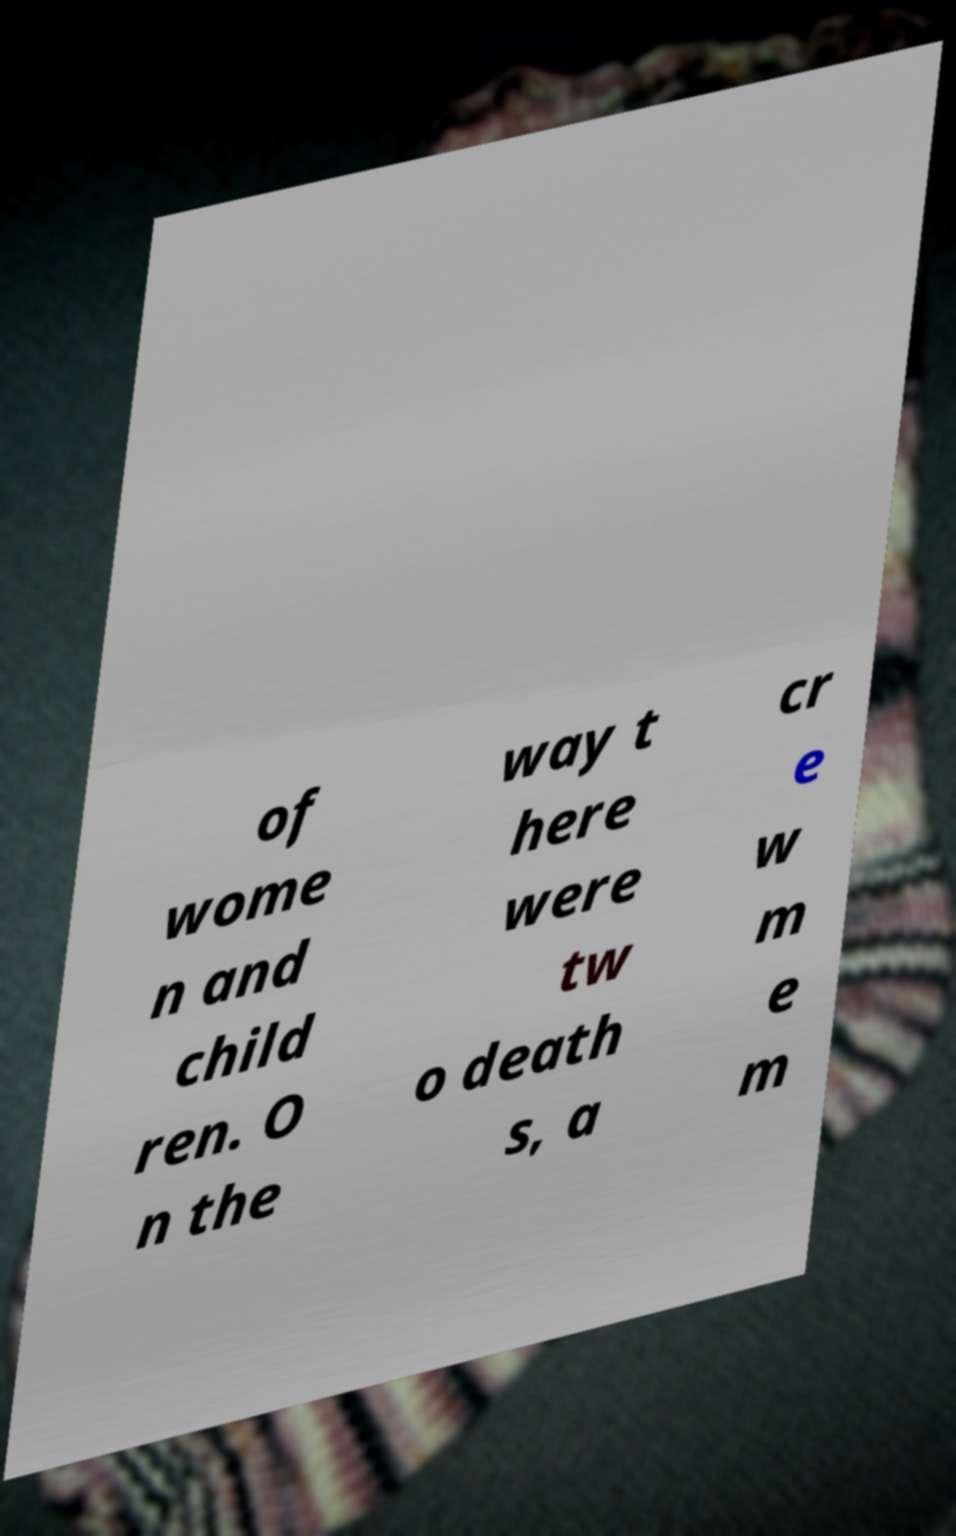I need the written content from this picture converted into text. Can you do that? of wome n and child ren. O n the way t here were tw o death s, a cr e w m e m 